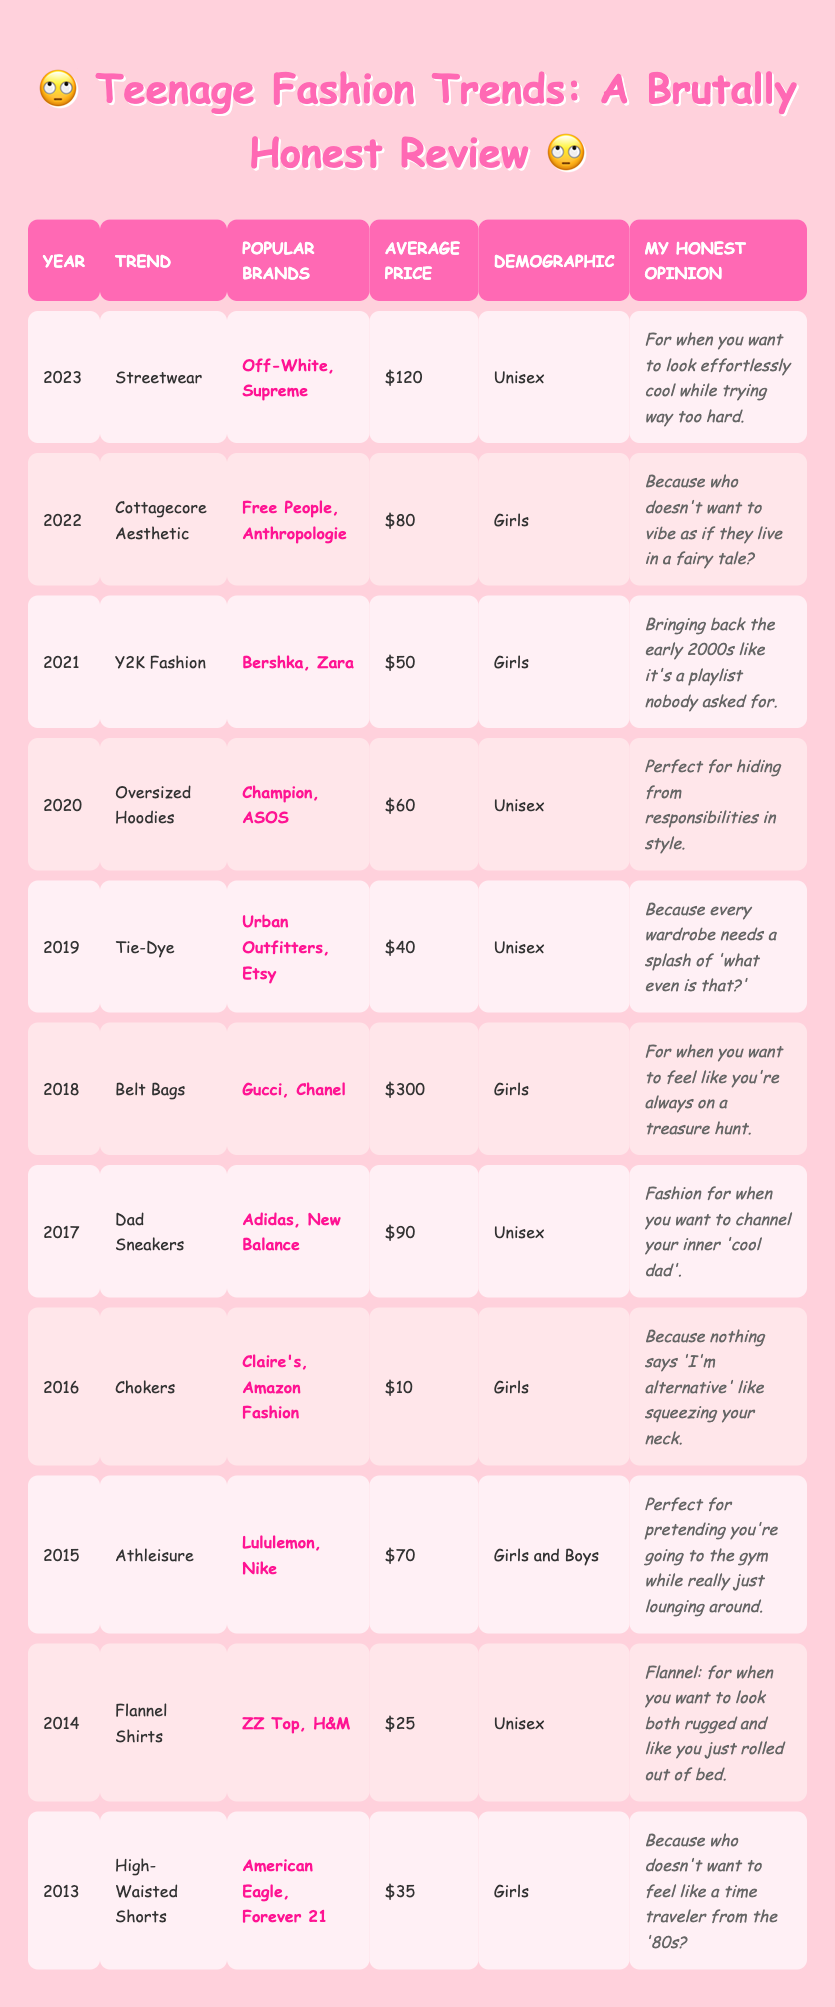What fashion trend had the highest average price in the last decade? In the table, I need to look for all the average prices listed for each trend. The highest price is for Belt Bags in 2018 at 300.
Answer: 300 Which trend was popular among both boys and girls? Looking through the demographic interest column, Athleisure in 2015 is noted to be appealing for both girls and boys.
Answer: Athleisure True or False: Chokers were the most affordable trend in the table. I can check the average price for Chokers, which is 10. Comparing this with other trends, it is indeed the lowest.
Answer: True What is the average price of trends from 2019 to 2023? I will calculate the average of the prices from these years: Tie-Dye (40), Oversized Hoodies (60), Y2K Fashion (50), Cottagecore Aesthetic (80), and Streetwear (120). The sum is 350, and there are 5 data points: 350/5 = 70.
Answer: 70 How many trends specifically targeted girls in the last decade? By counting the trends listed under the "Demographic" column, I find High-Waisted Shorts (2013), Chokers (2016), Belt Bags (2018), Cottagecore Aesthetic (2022), and Y2K Fashion (2021). That's 5 trends.
Answer: 5 Which trend appeared first in the list? I simply need to check the "Year" column; since the first year listed is 2013, the trend is High-Waisted Shorts.
Answer: High-Waisted Shorts What is the difference between the average price of Dad Sneakers and Flannel Shirts? From the table, I observe that Dad Sneakers cost 90 and Flannel Shirts cost 25. The difference is 90 - 25 = 65.
Answer: 65 What was the demographic interest for the trend in 2016? I can quickly locate the row for 2016 and find that Chokers were targeted at girls.
Answer: Girls How many trends had an average price above 100? I review the average prices: the only trend above 100 is Belt Bags (300) and Streetwear (120), making a total of 2 trends.
Answer: 2 